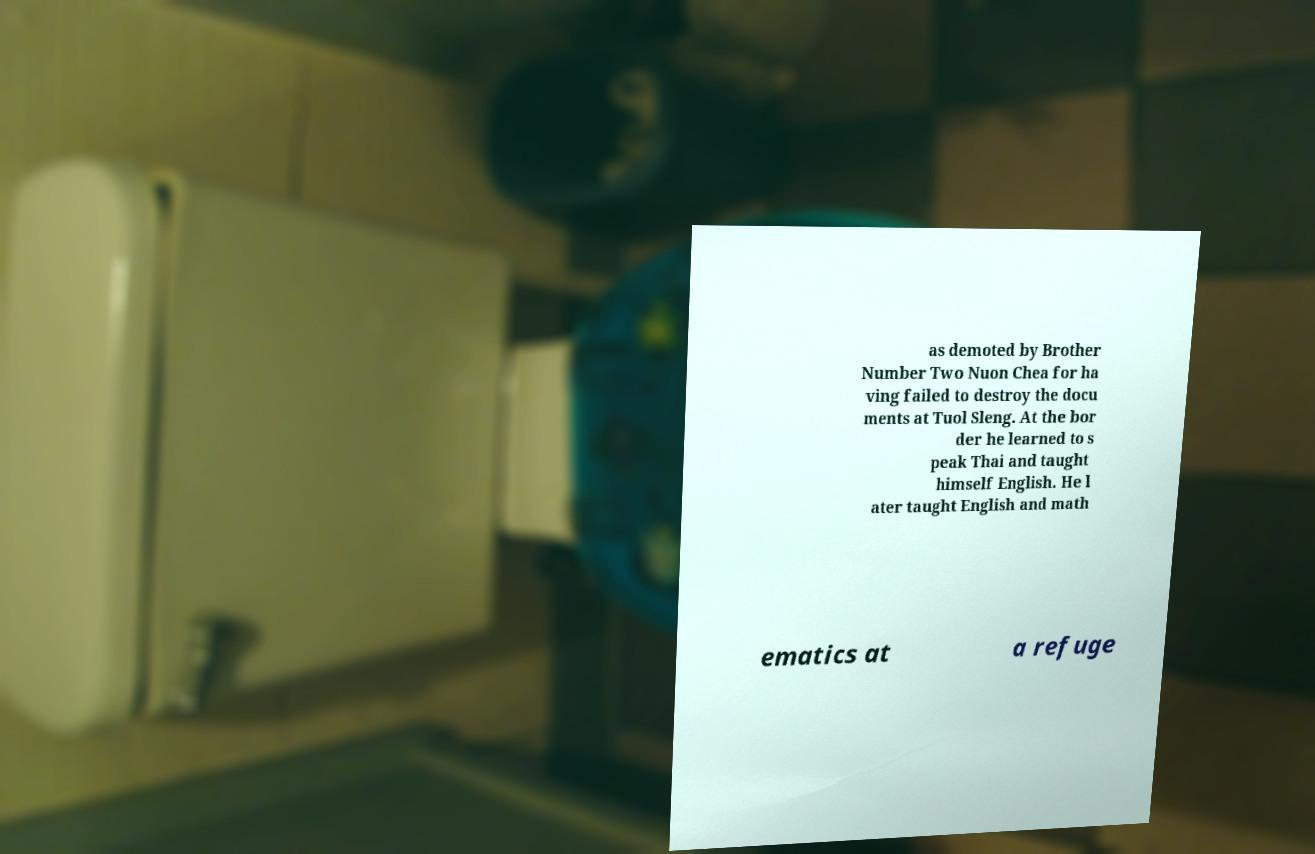Could you extract and type out the text from this image? as demoted by Brother Number Two Nuon Chea for ha ving failed to destroy the docu ments at Tuol Sleng. At the bor der he learned to s peak Thai and taught himself English. He l ater taught English and math ematics at a refuge 